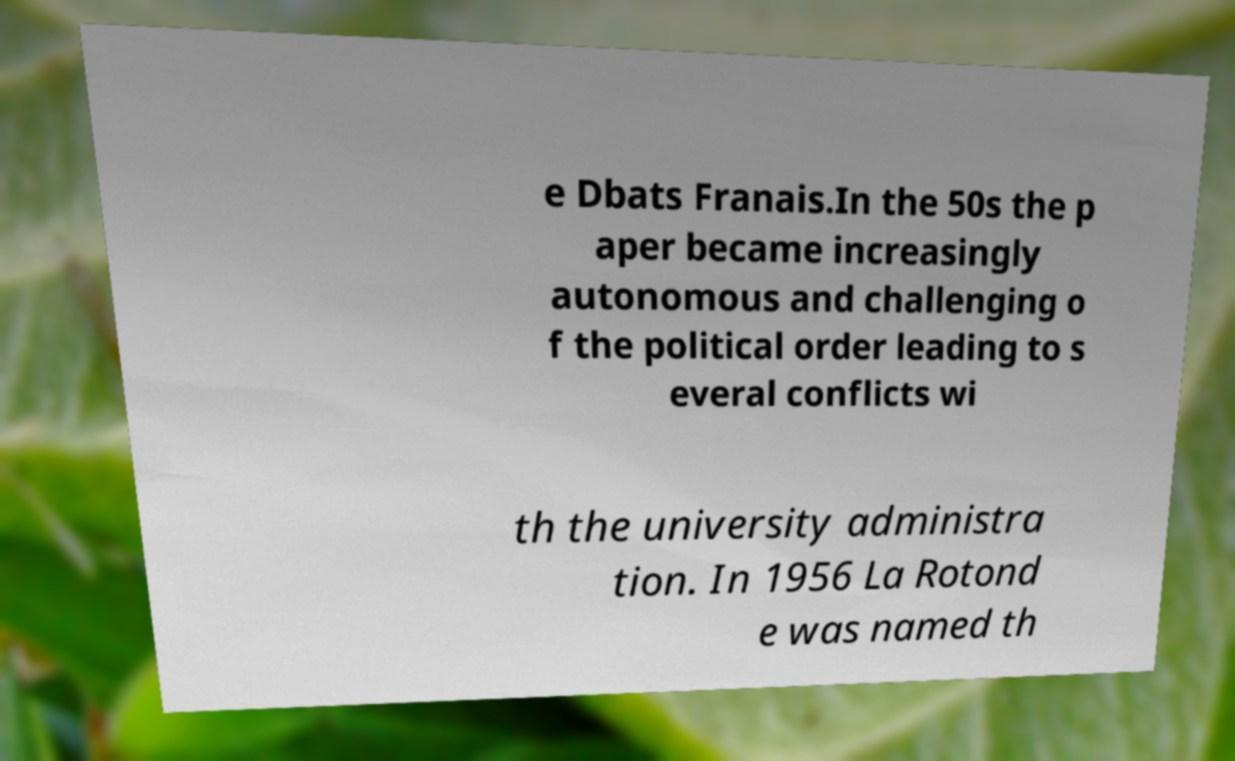Please read and relay the text visible in this image. What does it say? e Dbats Franais.In the 50s the p aper became increasingly autonomous and challenging o f the political order leading to s everal conflicts wi th the university administra tion. In 1956 La Rotond e was named th 